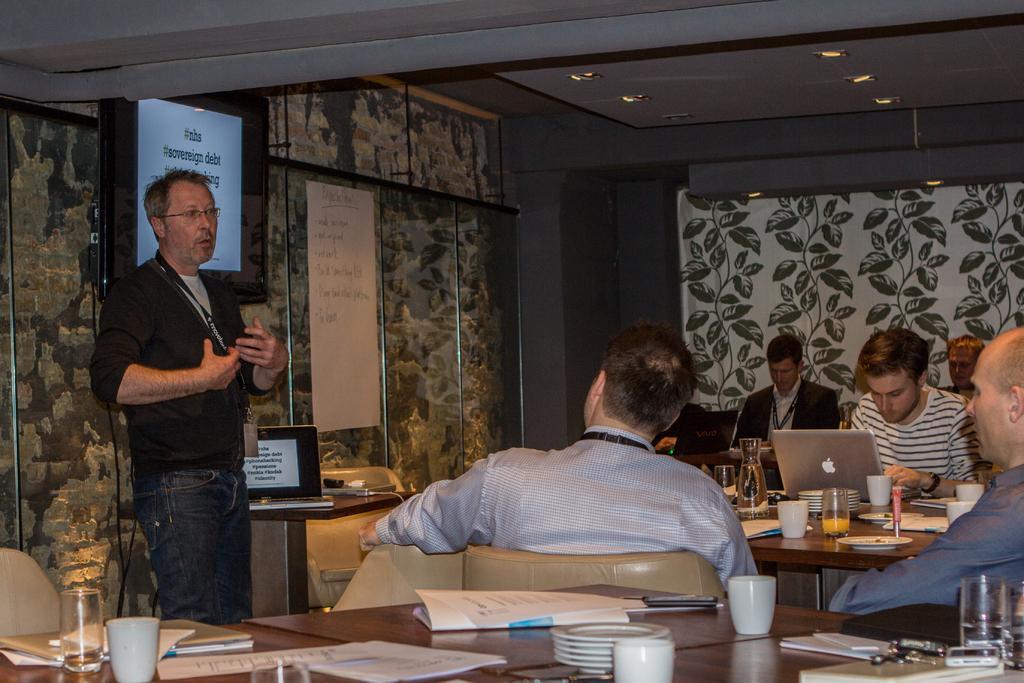Describe this image in one or two sentences. There are few people here sitting on the chair at the table. On the table there are laptops,glasses,plates. cups and a person on the left is talking to these people. In the background there is a screen,tablet,laptop,poster. 